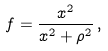Convert formula to latex. <formula><loc_0><loc_0><loc_500><loc_500>f = \frac { x ^ { 2 } } { x ^ { 2 } + \rho ^ { 2 } } \, ,</formula> 